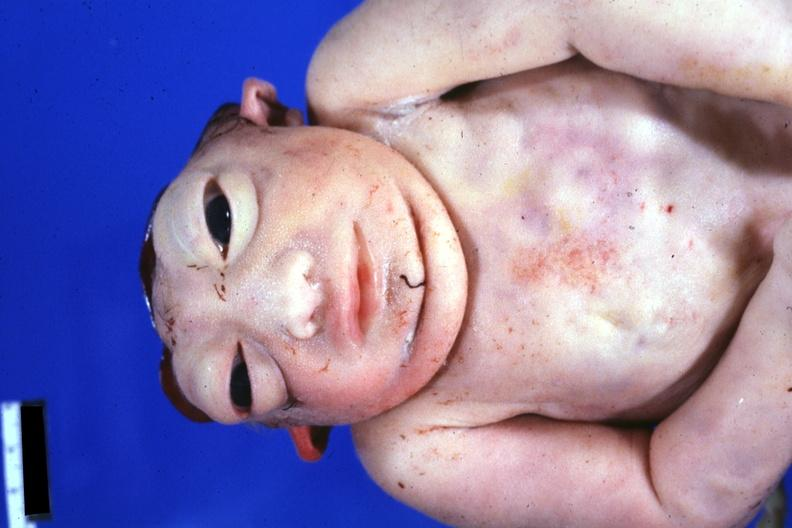s anencephaly present?
Answer the question using a single word or phrase. Yes 